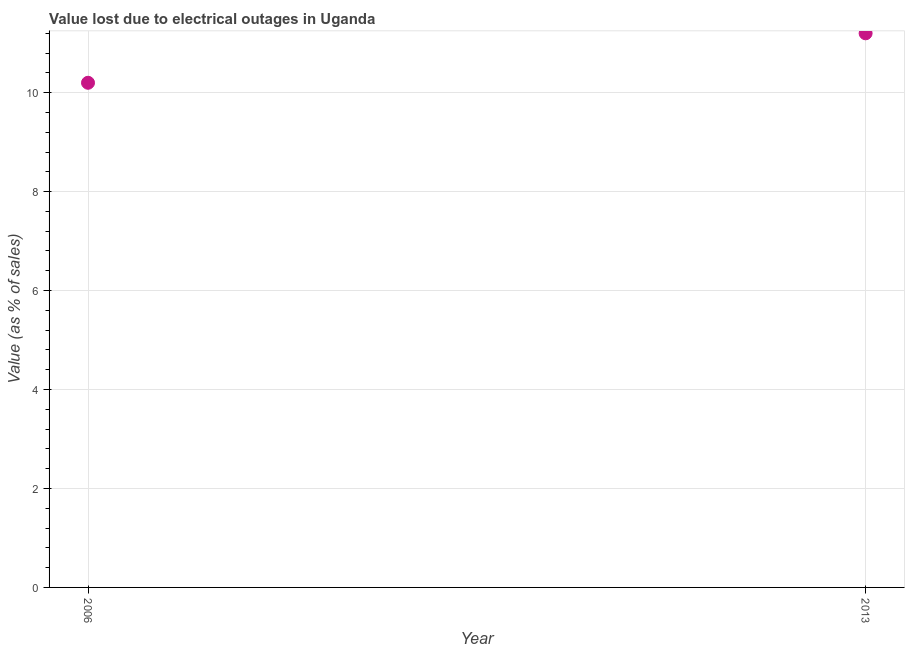What is the value lost due to electrical outages in 2006?
Provide a short and direct response. 10.2. Across all years, what is the maximum value lost due to electrical outages?
Offer a terse response. 11.2. What is the sum of the value lost due to electrical outages?
Your answer should be very brief. 21.4. What is the difference between the value lost due to electrical outages in 2006 and 2013?
Your answer should be very brief. -1. What is the median value lost due to electrical outages?
Offer a very short reply. 10.7. In how many years, is the value lost due to electrical outages greater than 8.4 %?
Give a very brief answer. 2. Do a majority of the years between 2006 and 2013 (inclusive) have value lost due to electrical outages greater than 3.6 %?
Make the answer very short. Yes. What is the ratio of the value lost due to electrical outages in 2006 to that in 2013?
Offer a very short reply. 0.91. Does the value lost due to electrical outages monotonically increase over the years?
Give a very brief answer. Yes. What is the difference between two consecutive major ticks on the Y-axis?
Provide a short and direct response. 2. Does the graph contain any zero values?
Keep it short and to the point. No. What is the title of the graph?
Your answer should be compact. Value lost due to electrical outages in Uganda. What is the label or title of the X-axis?
Provide a short and direct response. Year. What is the label or title of the Y-axis?
Give a very brief answer. Value (as % of sales). What is the Value (as % of sales) in 2006?
Provide a succinct answer. 10.2. What is the Value (as % of sales) in 2013?
Your answer should be compact. 11.2. What is the difference between the Value (as % of sales) in 2006 and 2013?
Your response must be concise. -1. What is the ratio of the Value (as % of sales) in 2006 to that in 2013?
Ensure brevity in your answer.  0.91. 